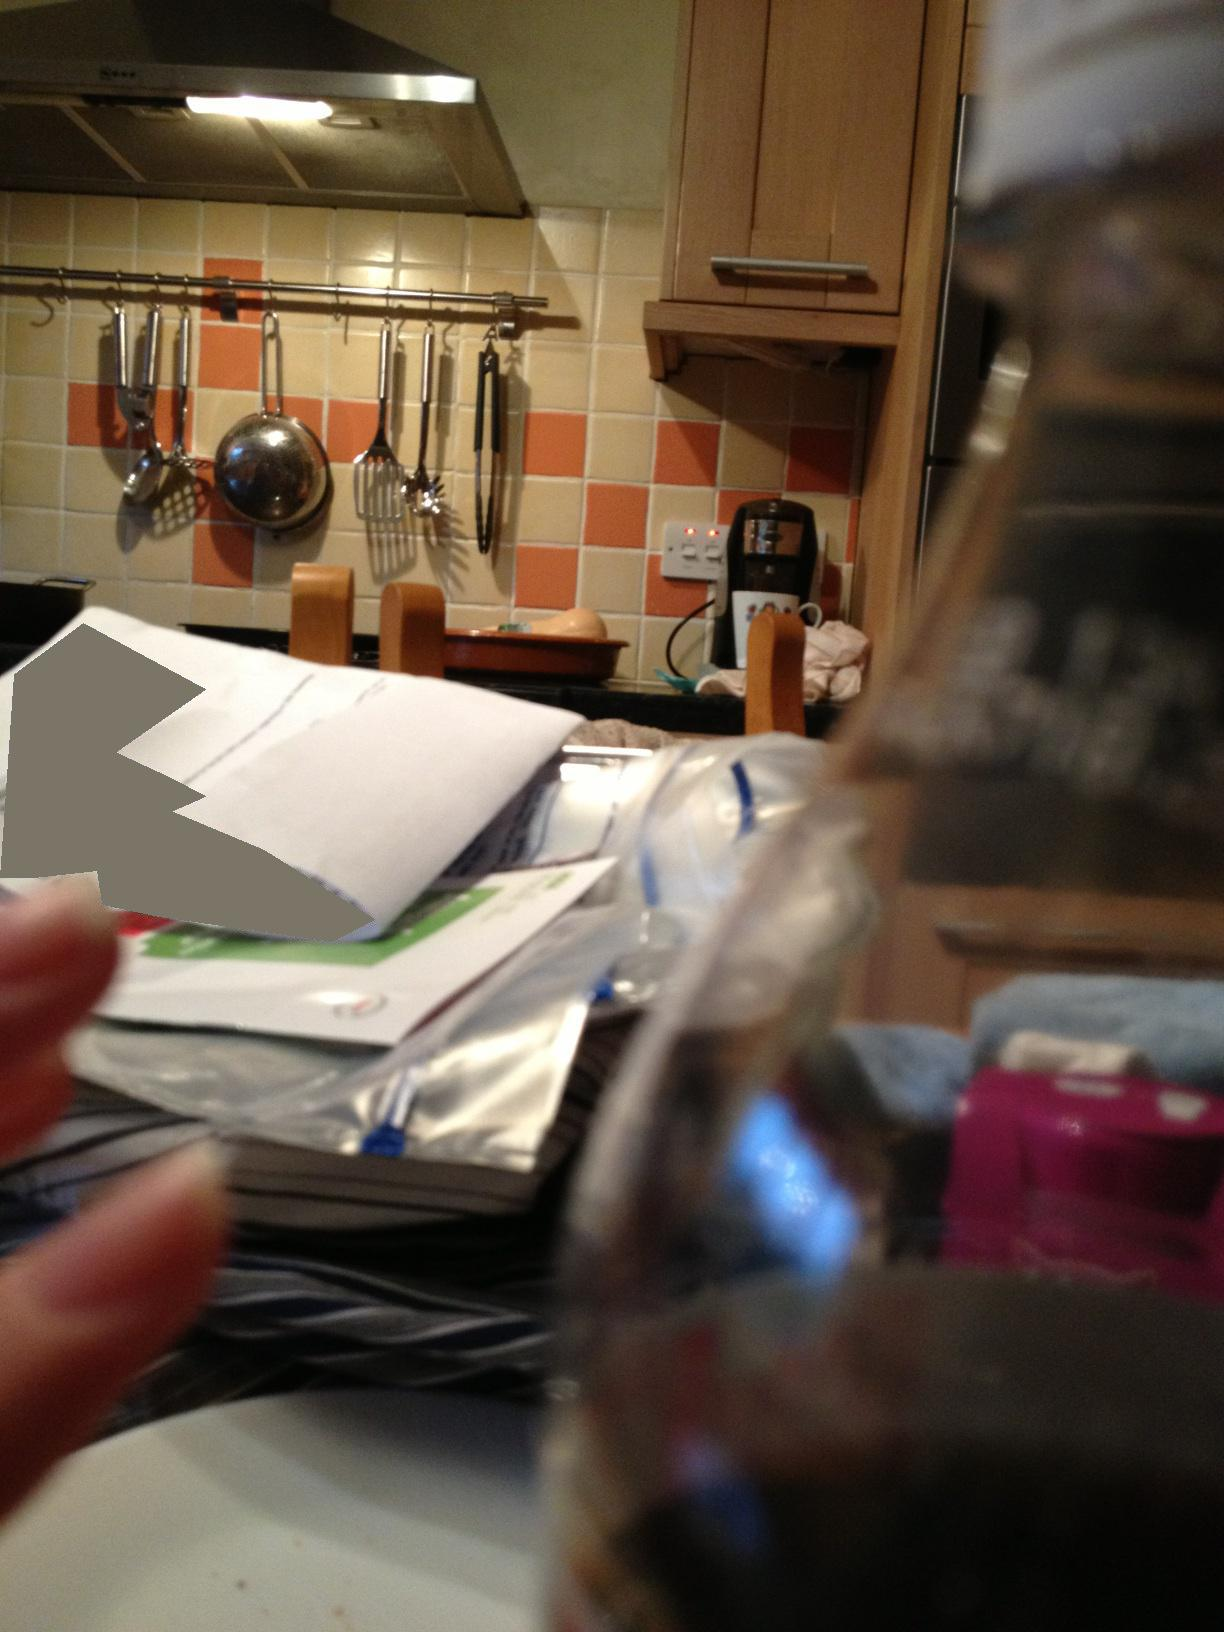What tasks might someone be doing in this kitchen? It looks like this kitchen is used for a range of activities. The presence of mail and paperwork might suggest someone is managing household tasks such as bills or correspondence. The utensils and appliances indicate cooking takes place here, and the chopping board suggests food prep might be a common task in this space. 